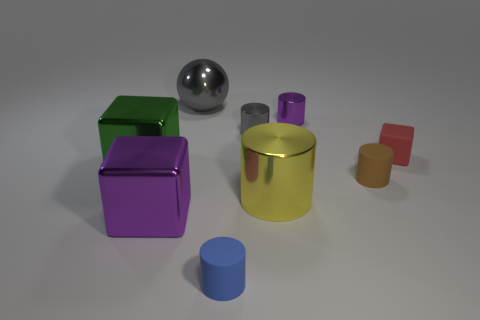Subtract all blue matte cylinders. How many cylinders are left? 4 Add 1 brown cubes. How many objects exist? 10 Subtract all brown cylinders. How many cylinders are left? 4 Subtract all balls. How many objects are left? 8 Subtract 0 red cylinders. How many objects are left? 9 Subtract all blue cubes. Subtract all red balls. How many cubes are left? 3 Subtract all small gray shiny cylinders. Subtract all small gray things. How many objects are left? 7 Add 5 purple cylinders. How many purple cylinders are left? 6 Add 5 big brown shiny blocks. How many big brown shiny blocks exist? 5 